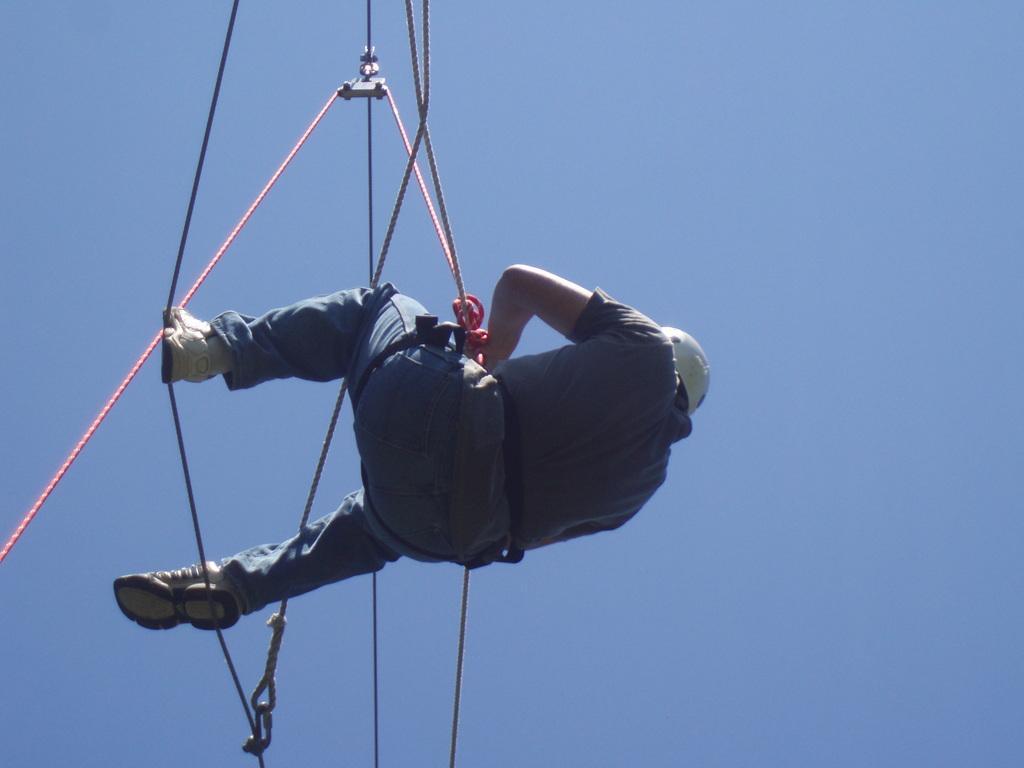Can you describe this image briefly? In the image there is a person hanging to rope in air, he had white helmet and shoe and above its sky. 